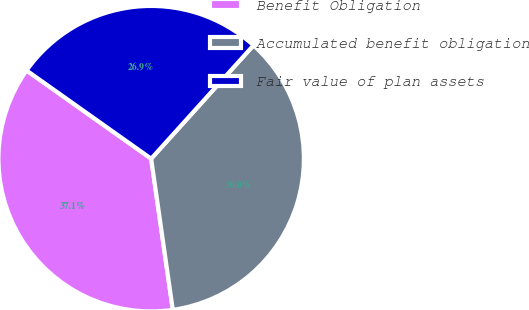Convert chart. <chart><loc_0><loc_0><loc_500><loc_500><pie_chart><fcel>Benefit Obligation<fcel>Accumulated benefit obligation<fcel>Fair value of plan assets<nl><fcel>37.07%<fcel>36.05%<fcel>26.88%<nl></chart> 